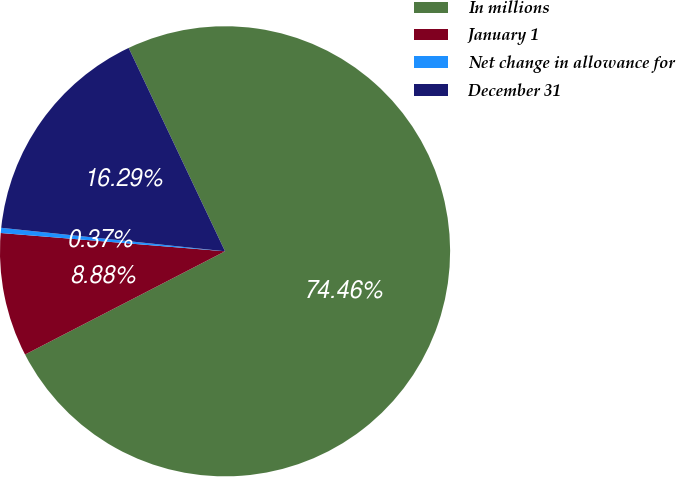<chart> <loc_0><loc_0><loc_500><loc_500><pie_chart><fcel>In millions<fcel>January 1<fcel>Net change in allowance for<fcel>December 31<nl><fcel>74.46%<fcel>8.88%<fcel>0.37%<fcel>16.29%<nl></chart> 